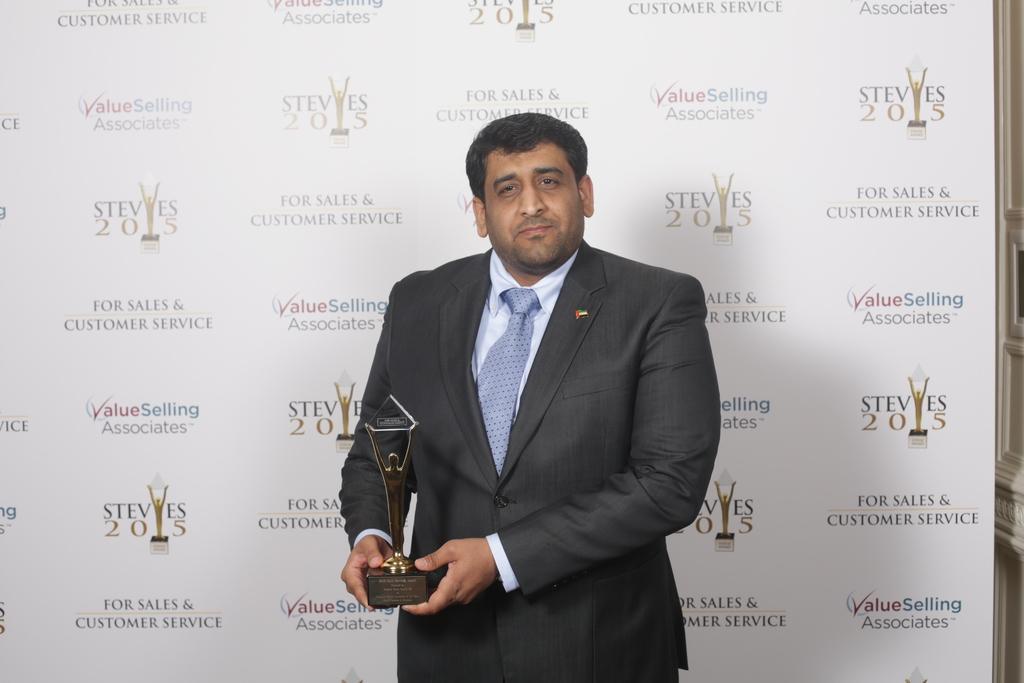In one or two sentences, can you explain what this image depicts? In this picture we can see a man wore a blazer, tie and holding a trophy with his hands and standing at the back of him we can see a banner. 